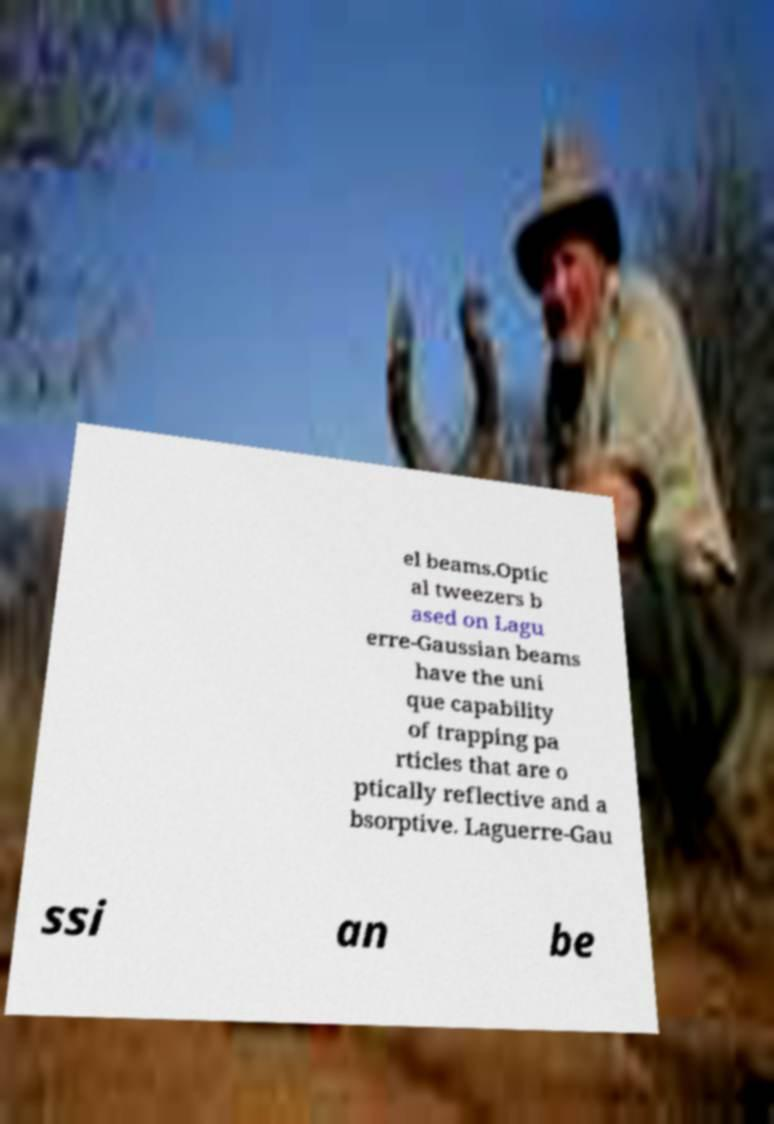Could you extract and type out the text from this image? el beams.Optic al tweezers b ased on Lagu erre-Gaussian beams have the uni que capability of trapping pa rticles that are o ptically reflective and a bsorptive. Laguerre-Gau ssi an be 